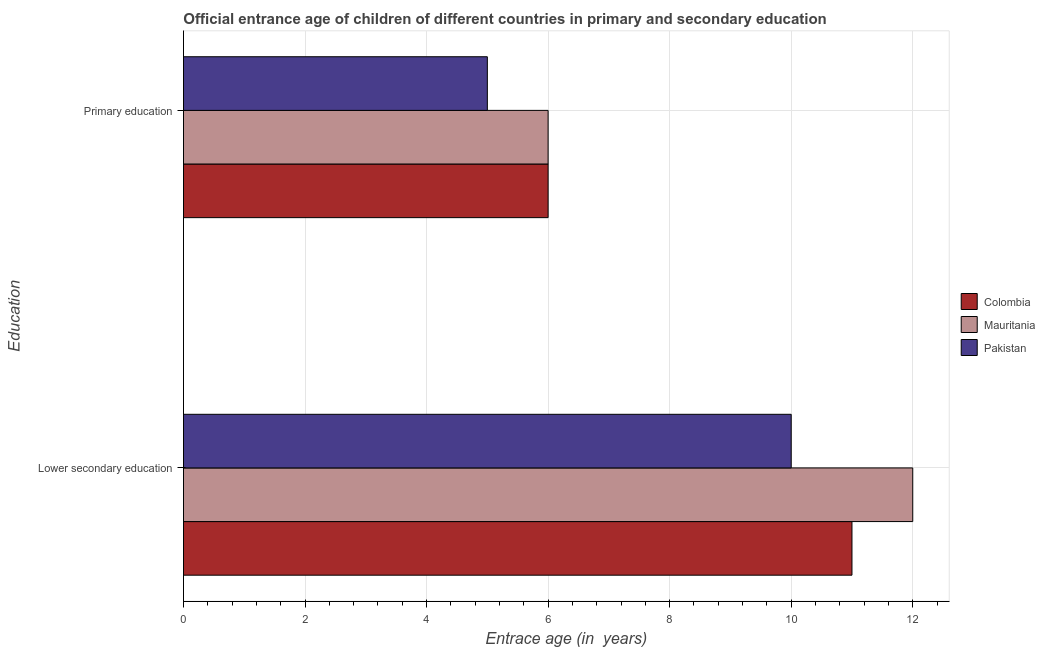How many groups of bars are there?
Provide a succinct answer. 2. How many bars are there on the 2nd tick from the top?
Offer a terse response. 3. How many bars are there on the 1st tick from the bottom?
Offer a very short reply. 3. What is the label of the 2nd group of bars from the top?
Offer a terse response. Lower secondary education. What is the entrance age of children in lower secondary education in Pakistan?
Your answer should be very brief. 10. Across all countries, what is the maximum entrance age of children in lower secondary education?
Offer a very short reply. 12. Across all countries, what is the minimum entrance age of chiildren in primary education?
Your answer should be compact. 5. In which country was the entrance age of children in lower secondary education maximum?
Ensure brevity in your answer.  Mauritania. What is the total entrance age of children in lower secondary education in the graph?
Your answer should be compact. 33. What is the difference between the entrance age of chiildren in primary education in Colombia and that in Pakistan?
Your answer should be compact. 1. What is the difference between the entrance age of chiildren in primary education in Mauritania and the entrance age of children in lower secondary education in Colombia?
Your answer should be very brief. -5. What is the average entrance age of chiildren in primary education per country?
Provide a succinct answer. 5.67. What is the difference between the entrance age of children in lower secondary education and entrance age of chiildren in primary education in Mauritania?
Your answer should be compact. 6. What is the ratio of the entrance age of children in lower secondary education in Mauritania to that in Colombia?
Give a very brief answer. 1.09. Is the entrance age of children in lower secondary education in Colombia less than that in Pakistan?
Make the answer very short. No. What does the 3rd bar from the top in Primary education represents?
Ensure brevity in your answer.  Colombia. What does the 2nd bar from the bottom in Primary education represents?
Keep it short and to the point. Mauritania. How many bars are there?
Provide a short and direct response. 6. Are all the bars in the graph horizontal?
Keep it short and to the point. Yes. Does the graph contain grids?
Your answer should be compact. Yes. Where does the legend appear in the graph?
Offer a terse response. Center right. How many legend labels are there?
Make the answer very short. 3. How are the legend labels stacked?
Provide a succinct answer. Vertical. What is the title of the graph?
Keep it short and to the point. Official entrance age of children of different countries in primary and secondary education. What is the label or title of the X-axis?
Make the answer very short. Entrace age (in  years). What is the label or title of the Y-axis?
Offer a terse response. Education. What is the Entrace age (in  years) in Colombia in Lower secondary education?
Provide a succinct answer. 11. What is the Entrace age (in  years) in Pakistan in Primary education?
Provide a short and direct response. 5. Across all Education, what is the maximum Entrace age (in  years) of Colombia?
Make the answer very short. 11. Across all Education, what is the maximum Entrace age (in  years) in Mauritania?
Your response must be concise. 12. Across all Education, what is the maximum Entrace age (in  years) of Pakistan?
Your answer should be compact. 10. Across all Education, what is the minimum Entrace age (in  years) of Mauritania?
Provide a short and direct response. 6. What is the total Entrace age (in  years) of Colombia in the graph?
Your answer should be compact. 17. What is the total Entrace age (in  years) of Mauritania in the graph?
Your answer should be very brief. 18. What is the difference between the Entrace age (in  years) in Colombia in Lower secondary education and that in Primary education?
Ensure brevity in your answer.  5. What is the difference between the Entrace age (in  years) of Mauritania in Lower secondary education and that in Primary education?
Make the answer very short. 6. What is the average Entrace age (in  years) in Colombia per Education?
Keep it short and to the point. 8.5. What is the difference between the Entrace age (in  years) of Colombia and Entrace age (in  years) of Pakistan in Lower secondary education?
Ensure brevity in your answer.  1. What is the difference between the Entrace age (in  years) in Mauritania and Entrace age (in  years) in Pakistan in Lower secondary education?
Keep it short and to the point. 2. What is the ratio of the Entrace age (in  years) of Colombia in Lower secondary education to that in Primary education?
Your answer should be very brief. 1.83. What is the ratio of the Entrace age (in  years) of Mauritania in Lower secondary education to that in Primary education?
Your answer should be very brief. 2. What is the ratio of the Entrace age (in  years) of Pakistan in Lower secondary education to that in Primary education?
Offer a terse response. 2. What is the difference between the highest and the second highest Entrace age (in  years) of Colombia?
Ensure brevity in your answer.  5. What is the difference between the highest and the second highest Entrace age (in  years) in Mauritania?
Keep it short and to the point. 6. What is the difference between the highest and the lowest Entrace age (in  years) of Colombia?
Provide a succinct answer. 5. 